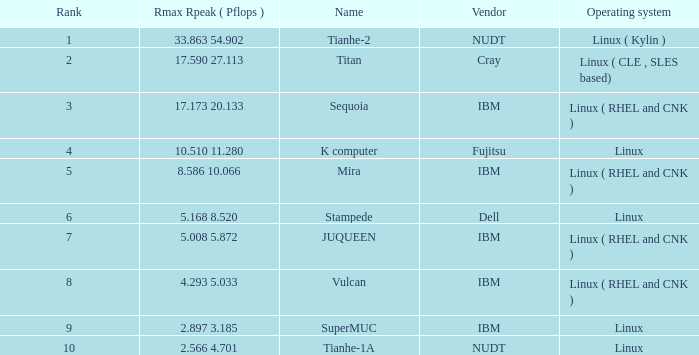What is the name of Rank 5? Mira. 